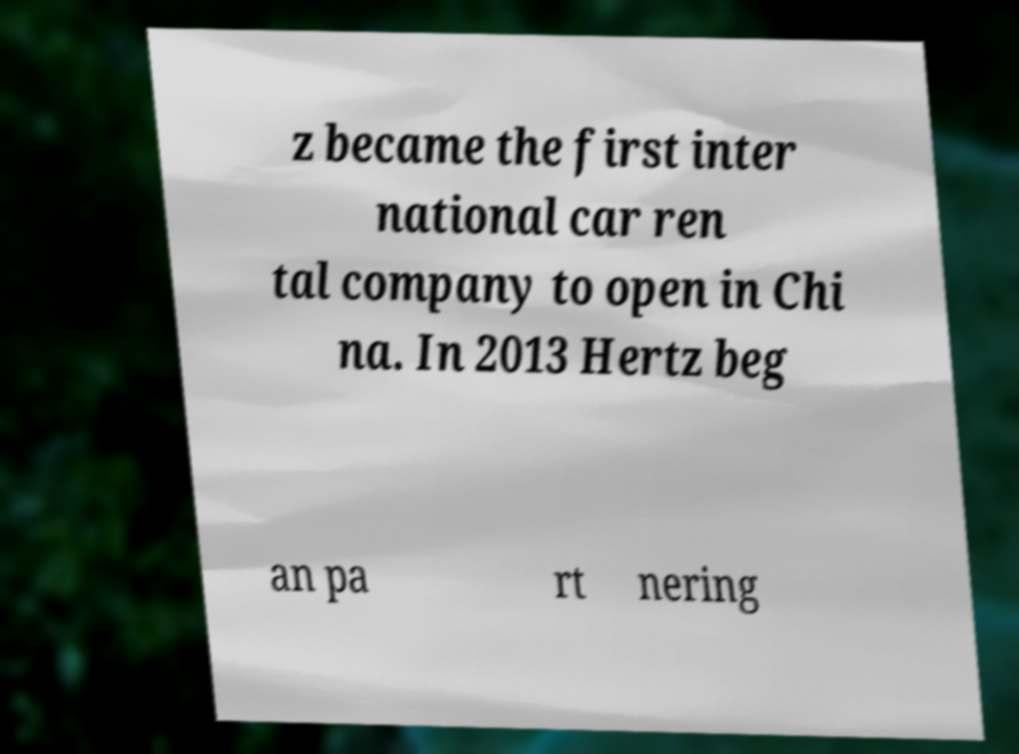Please identify and transcribe the text found in this image. z became the first inter national car ren tal company to open in Chi na. In 2013 Hertz beg an pa rt nering 